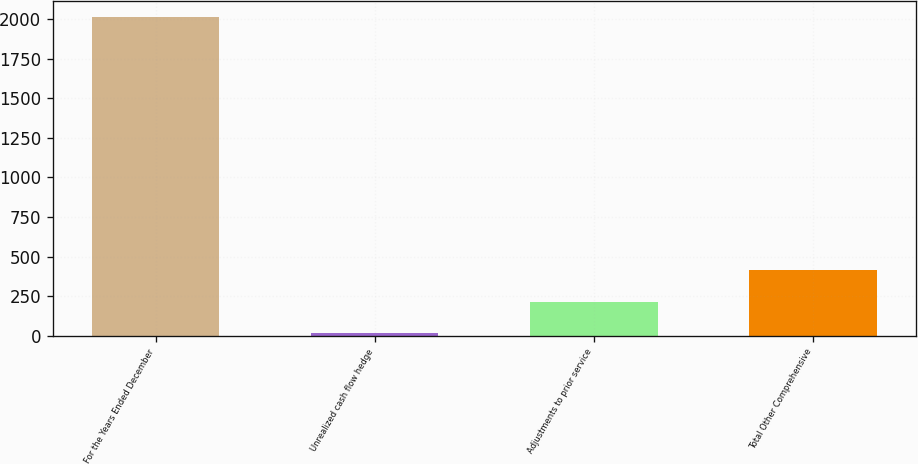Convert chart. <chart><loc_0><loc_0><loc_500><loc_500><bar_chart><fcel>For the Years Ended December<fcel>Unrealized cash flow hedge<fcel>Adjustments to prior service<fcel>Total Other Comprehensive<nl><fcel>2012<fcel>15.2<fcel>214.88<fcel>414.56<nl></chart> 